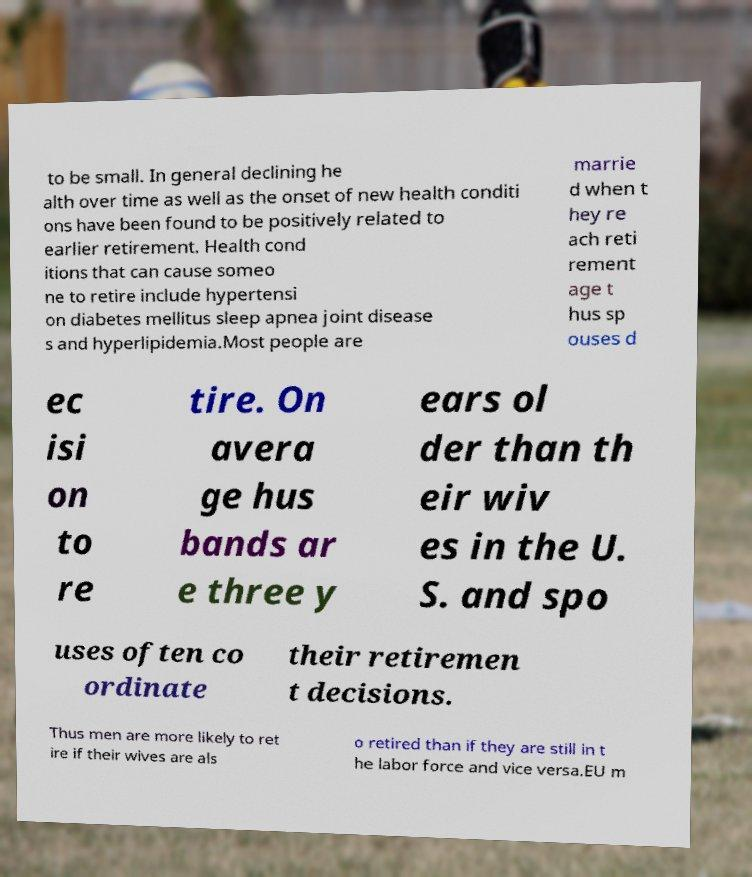I need the written content from this picture converted into text. Can you do that? to be small. In general declining he alth over time as well as the onset of new health conditi ons have been found to be positively related to earlier retirement. Health cond itions that can cause someo ne to retire include hypertensi on diabetes mellitus sleep apnea joint disease s and hyperlipidemia.Most people are marrie d when t hey re ach reti rement age t hus sp ouses d ec isi on to re tire. On avera ge hus bands ar e three y ears ol der than th eir wiv es in the U. S. and spo uses often co ordinate their retiremen t decisions. Thus men are more likely to ret ire if their wives are als o retired than if they are still in t he labor force and vice versa.EU m 